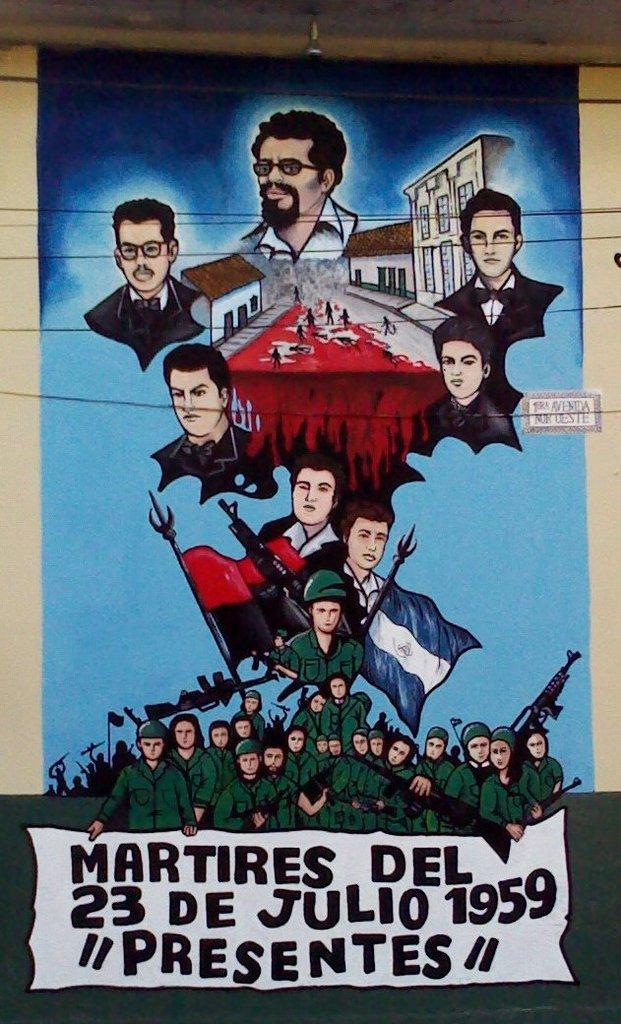What year is this poster from?
Keep it short and to the point. 1959. What does the top line on the poster say?
Offer a terse response. Martires del. 